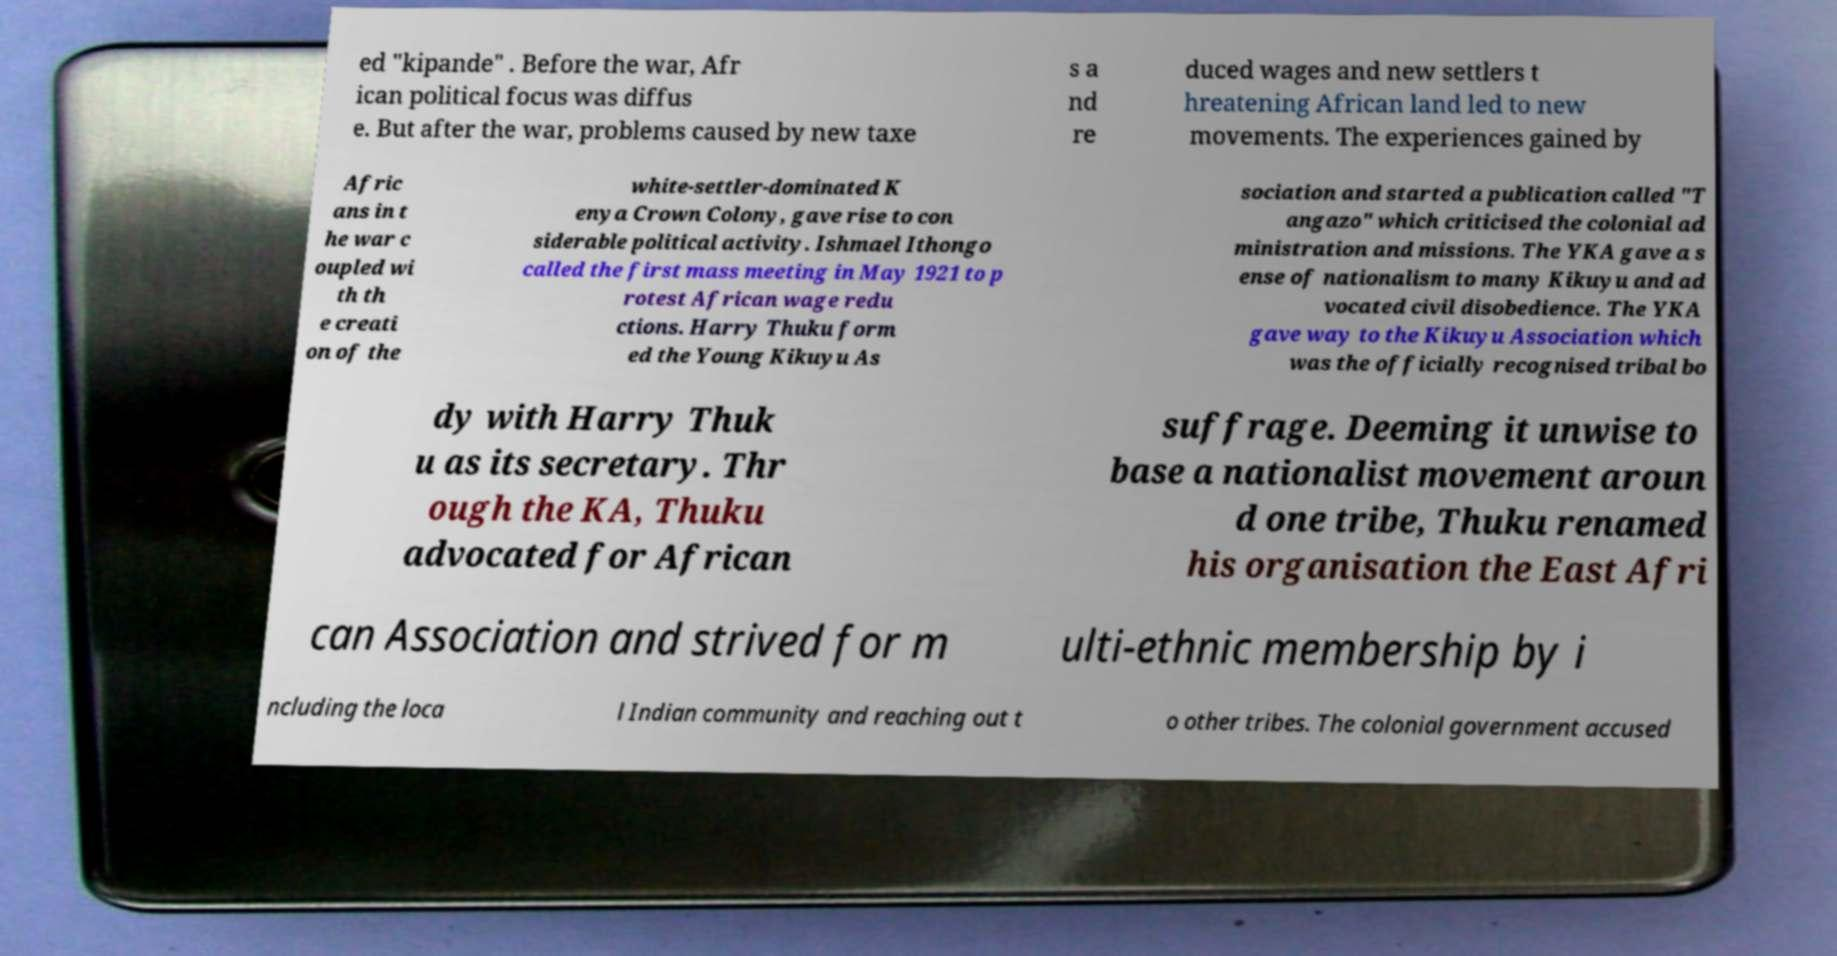Please identify and transcribe the text found in this image. ed "kipande" . Before the war, Afr ican political focus was diffus e. But after the war, problems caused by new taxe s a nd re duced wages and new settlers t hreatening African land led to new movements. The experiences gained by Afric ans in t he war c oupled wi th th e creati on of the white-settler-dominated K enya Crown Colony, gave rise to con siderable political activity. Ishmael Ithongo called the first mass meeting in May 1921 to p rotest African wage redu ctions. Harry Thuku form ed the Young Kikuyu As sociation and started a publication called "T angazo" which criticised the colonial ad ministration and missions. The YKA gave a s ense of nationalism to many Kikuyu and ad vocated civil disobedience. The YKA gave way to the Kikuyu Association which was the officially recognised tribal bo dy with Harry Thuk u as its secretary. Thr ough the KA, Thuku advocated for African suffrage. Deeming it unwise to base a nationalist movement aroun d one tribe, Thuku renamed his organisation the East Afri can Association and strived for m ulti-ethnic membership by i ncluding the loca l Indian community and reaching out t o other tribes. The colonial government accused 